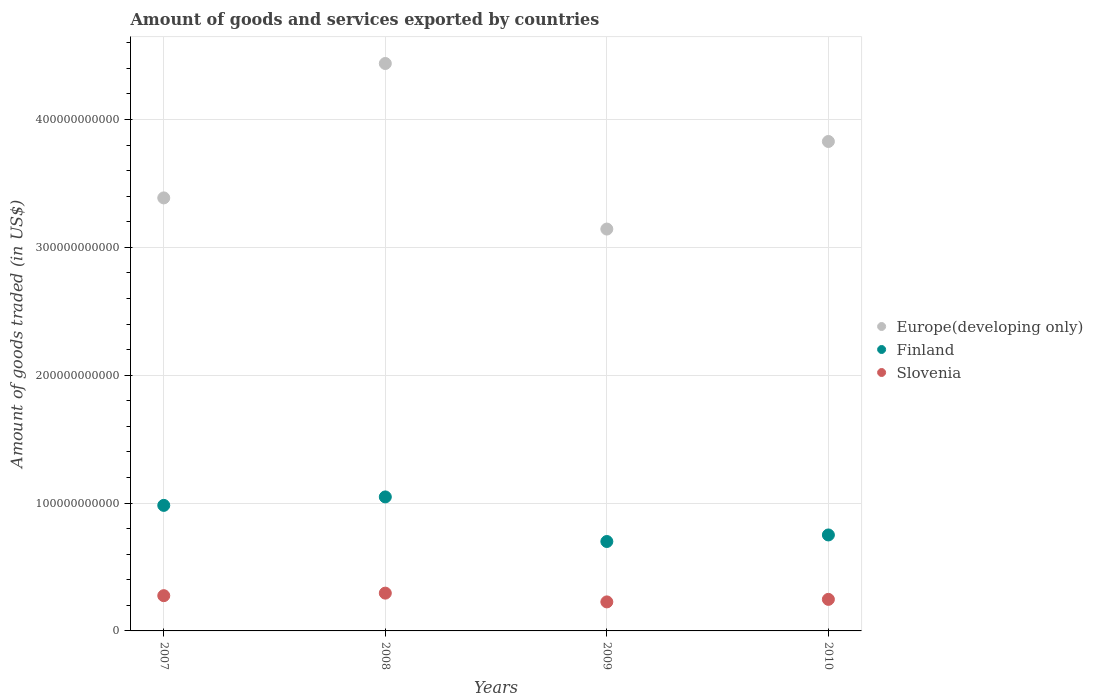Is the number of dotlines equal to the number of legend labels?
Keep it short and to the point. Yes. What is the total amount of goods and services exported in Finland in 2010?
Your answer should be very brief. 7.51e+1. Across all years, what is the maximum total amount of goods and services exported in Finland?
Provide a succinct answer. 1.05e+11. Across all years, what is the minimum total amount of goods and services exported in Slovenia?
Provide a short and direct response. 2.27e+1. What is the total total amount of goods and services exported in Slovenia in the graph?
Keep it short and to the point. 1.05e+11. What is the difference between the total amount of goods and services exported in Finland in 2007 and that in 2009?
Your answer should be compact. 2.83e+1. What is the difference between the total amount of goods and services exported in Slovenia in 2009 and the total amount of goods and services exported in Europe(developing only) in 2008?
Your answer should be compact. -4.21e+11. What is the average total amount of goods and services exported in Finland per year?
Your response must be concise. 8.70e+1. In the year 2007, what is the difference between the total amount of goods and services exported in Finland and total amount of goods and services exported in Europe(developing only)?
Offer a very short reply. -2.40e+11. What is the ratio of the total amount of goods and services exported in Finland in 2009 to that in 2010?
Keep it short and to the point. 0.93. Is the total amount of goods and services exported in Europe(developing only) in 2009 less than that in 2010?
Make the answer very short. Yes. Is the difference between the total amount of goods and services exported in Finland in 2009 and 2010 greater than the difference between the total amount of goods and services exported in Europe(developing only) in 2009 and 2010?
Offer a terse response. Yes. What is the difference between the highest and the second highest total amount of goods and services exported in Slovenia?
Provide a short and direct response. 1.98e+09. What is the difference between the highest and the lowest total amount of goods and services exported in Finland?
Provide a succinct answer. 3.49e+1. Is the total amount of goods and services exported in Slovenia strictly greater than the total amount of goods and services exported in Finland over the years?
Ensure brevity in your answer.  No. What is the difference between two consecutive major ticks on the Y-axis?
Your response must be concise. 1.00e+11. Does the graph contain grids?
Your response must be concise. Yes. Where does the legend appear in the graph?
Give a very brief answer. Center right. How many legend labels are there?
Make the answer very short. 3. How are the legend labels stacked?
Your response must be concise. Vertical. What is the title of the graph?
Provide a succinct answer. Amount of goods and services exported by countries. Does "Ethiopia" appear as one of the legend labels in the graph?
Ensure brevity in your answer.  No. What is the label or title of the Y-axis?
Your response must be concise. Amount of goods traded (in US$). What is the Amount of goods traded (in US$) of Europe(developing only) in 2007?
Make the answer very short. 3.39e+11. What is the Amount of goods traded (in US$) of Finland in 2007?
Your answer should be compact. 9.82e+1. What is the Amount of goods traded (in US$) in Slovenia in 2007?
Ensure brevity in your answer.  2.76e+1. What is the Amount of goods traded (in US$) of Europe(developing only) in 2008?
Offer a very short reply. 4.44e+11. What is the Amount of goods traded (in US$) in Finland in 2008?
Your response must be concise. 1.05e+11. What is the Amount of goods traded (in US$) in Slovenia in 2008?
Offer a very short reply. 2.96e+1. What is the Amount of goods traded (in US$) of Europe(developing only) in 2009?
Ensure brevity in your answer.  3.14e+11. What is the Amount of goods traded (in US$) of Finland in 2009?
Provide a succinct answer. 6.99e+1. What is the Amount of goods traded (in US$) in Slovenia in 2009?
Offer a very short reply. 2.27e+1. What is the Amount of goods traded (in US$) of Europe(developing only) in 2010?
Your answer should be compact. 3.83e+11. What is the Amount of goods traded (in US$) in Finland in 2010?
Your answer should be compact. 7.51e+1. What is the Amount of goods traded (in US$) in Slovenia in 2010?
Your answer should be compact. 2.47e+1. Across all years, what is the maximum Amount of goods traded (in US$) of Europe(developing only)?
Your answer should be very brief. 4.44e+11. Across all years, what is the maximum Amount of goods traded (in US$) of Finland?
Your answer should be compact. 1.05e+11. Across all years, what is the maximum Amount of goods traded (in US$) in Slovenia?
Give a very brief answer. 2.96e+1. Across all years, what is the minimum Amount of goods traded (in US$) of Europe(developing only)?
Ensure brevity in your answer.  3.14e+11. Across all years, what is the minimum Amount of goods traded (in US$) in Finland?
Give a very brief answer. 6.99e+1. Across all years, what is the minimum Amount of goods traded (in US$) of Slovenia?
Your response must be concise. 2.27e+1. What is the total Amount of goods traded (in US$) in Europe(developing only) in the graph?
Provide a short and direct response. 1.48e+12. What is the total Amount of goods traded (in US$) of Finland in the graph?
Ensure brevity in your answer.  3.48e+11. What is the total Amount of goods traded (in US$) of Slovenia in the graph?
Your response must be concise. 1.05e+11. What is the difference between the Amount of goods traded (in US$) of Europe(developing only) in 2007 and that in 2008?
Your response must be concise. -1.05e+11. What is the difference between the Amount of goods traded (in US$) in Finland in 2007 and that in 2008?
Keep it short and to the point. -6.61e+09. What is the difference between the Amount of goods traded (in US$) in Slovenia in 2007 and that in 2008?
Your response must be concise. -1.98e+09. What is the difference between the Amount of goods traded (in US$) in Europe(developing only) in 2007 and that in 2009?
Make the answer very short. 2.44e+1. What is the difference between the Amount of goods traded (in US$) of Finland in 2007 and that in 2009?
Offer a terse response. 2.83e+1. What is the difference between the Amount of goods traded (in US$) of Slovenia in 2007 and that in 2009?
Provide a short and direct response. 4.87e+09. What is the difference between the Amount of goods traded (in US$) of Europe(developing only) in 2007 and that in 2010?
Ensure brevity in your answer.  -4.41e+1. What is the difference between the Amount of goods traded (in US$) in Finland in 2007 and that in 2010?
Your answer should be compact. 2.31e+1. What is the difference between the Amount of goods traded (in US$) in Slovenia in 2007 and that in 2010?
Provide a short and direct response. 2.89e+09. What is the difference between the Amount of goods traded (in US$) of Europe(developing only) in 2008 and that in 2009?
Your answer should be very brief. 1.29e+11. What is the difference between the Amount of goods traded (in US$) in Finland in 2008 and that in 2009?
Provide a short and direct response. 3.49e+1. What is the difference between the Amount of goods traded (in US$) of Slovenia in 2008 and that in 2009?
Make the answer very short. 6.85e+09. What is the difference between the Amount of goods traded (in US$) in Europe(developing only) in 2008 and that in 2010?
Make the answer very short. 6.10e+1. What is the difference between the Amount of goods traded (in US$) of Finland in 2008 and that in 2010?
Give a very brief answer. 2.97e+1. What is the difference between the Amount of goods traded (in US$) in Slovenia in 2008 and that in 2010?
Your answer should be compact. 4.87e+09. What is the difference between the Amount of goods traded (in US$) of Europe(developing only) in 2009 and that in 2010?
Provide a succinct answer. -6.85e+1. What is the difference between the Amount of goods traded (in US$) of Finland in 2009 and that in 2010?
Offer a terse response. -5.12e+09. What is the difference between the Amount of goods traded (in US$) of Slovenia in 2009 and that in 2010?
Your answer should be compact. -1.98e+09. What is the difference between the Amount of goods traded (in US$) in Europe(developing only) in 2007 and the Amount of goods traded (in US$) in Finland in 2008?
Give a very brief answer. 2.34e+11. What is the difference between the Amount of goods traded (in US$) of Europe(developing only) in 2007 and the Amount of goods traded (in US$) of Slovenia in 2008?
Keep it short and to the point. 3.09e+11. What is the difference between the Amount of goods traded (in US$) of Finland in 2007 and the Amount of goods traded (in US$) of Slovenia in 2008?
Provide a succinct answer. 6.86e+1. What is the difference between the Amount of goods traded (in US$) in Europe(developing only) in 2007 and the Amount of goods traded (in US$) in Finland in 2009?
Offer a terse response. 2.69e+11. What is the difference between the Amount of goods traded (in US$) of Europe(developing only) in 2007 and the Amount of goods traded (in US$) of Slovenia in 2009?
Offer a terse response. 3.16e+11. What is the difference between the Amount of goods traded (in US$) in Finland in 2007 and the Amount of goods traded (in US$) in Slovenia in 2009?
Ensure brevity in your answer.  7.55e+1. What is the difference between the Amount of goods traded (in US$) of Europe(developing only) in 2007 and the Amount of goods traded (in US$) of Finland in 2010?
Provide a succinct answer. 2.64e+11. What is the difference between the Amount of goods traded (in US$) in Europe(developing only) in 2007 and the Amount of goods traded (in US$) in Slovenia in 2010?
Your answer should be very brief. 3.14e+11. What is the difference between the Amount of goods traded (in US$) of Finland in 2007 and the Amount of goods traded (in US$) of Slovenia in 2010?
Your response must be concise. 7.35e+1. What is the difference between the Amount of goods traded (in US$) in Europe(developing only) in 2008 and the Amount of goods traded (in US$) in Finland in 2009?
Offer a terse response. 3.74e+11. What is the difference between the Amount of goods traded (in US$) of Europe(developing only) in 2008 and the Amount of goods traded (in US$) of Slovenia in 2009?
Make the answer very short. 4.21e+11. What is the difference between the Amount of goods traded (in US$) of Finland in 2008 and the Amount of goods traded (in US$) of Slovenia in 2009?
Provide a short and direct response. 8.21e+1. What is the difference between the Amount of goods traded (in US$) of Europe(developing only) in 2008 and the Amount of goods traded (in US$) of Finland in 2010?
Your answer should be very brief. 3.69e+11. What is the difference between the Amount of goods traded (in US$) in Europe(developing only) in 2008 and the Amount of goods traded (in US$) in Slovenia in 2010?
Provide a succinct answer. 4.19e+11. What is the difference between the Amount of goods traded (in US$) of Finland in 2008 and the Amount of goods traded (in US$) of Slovenia in 2010?
Provide a short and direct response. 8.01e+1. What is the difference between the Amount of goods traded (in US$) of Europe(developing only) in 2009 and the Amount of goods traded (in US$) of Finland in 2010?
Keep it short and to the point. 2.39e+11. What is the difference between the Amount of goods traded (in US$) of Europe(developing only) in 2009 and the Amount of goods traded (in US$) of Slovenia in 2010?
Offer a very short reply. 2.90e+11. What is the difference between the Amount of goods traded (in US$) in Finland in 2009 and the Amount of goods traded (in US$) in Slovenia in 2010?
Your answer should be compact. 4.53e+1. What is the average Amount of goods traded (in US$) of Europe(developing only) per year?
Ensure brevity in your answer.  3.70e+11. What is the average Amount of goods traded (in US$) of Finland per year?
Your answer should be compact. 8.70e+1. What is the average Amount of goods traded (in US$) of Slovenia per year?
Your response must be concise. 2.61e+1. In the year 2007, what is the difference between the Amount of goods traded (in US$) of Europe(developing only) and Amount of goods traded (in US$) of Finland?
Your response must be concise. 2.40e+11. In the year 2007, what is the difference between the Amount of goods traded (in US$) in Europe(developing only) and Amount of goods traded (in US$) in Slovenia?
Offer a very short reply. 3.11e+11. In the year 2007, what is the difference between the Amount of goods traded (in US$) of Finland and Amount of goods traded (in US$) of Slovenia?
Provide a succinct answer. 7.06e+1. In the year 2008, what is the difference between the Amount of goods traded (in US$) in Europe(developing only) and Amount of goods traded (in US$) in Finland?
Keep it short and to the point. 3.39e+11. In the year 2008, what is the difference between the Amount of goods traded (in US$) of Europe(developing only) and Amount of goods traded (in US$) of Slovenia?
Keep it short and to the point. 4.14e+11. In the year 2008, what is the difference between the Amount of goods traded (in US$) in Finland and Amount of goods traded (in US$) in Slovenia?
Ensure brevity in your answer.  7.53e+1. In the year 2009, what is the difference between the Amount of goods traded (in US$) of Europe(developing only) and Amount of goods traded (in US$) of Finland?
Offer a terse response. 2.44e+11. In the year 2009, what is the difference between the Amount of goods traded (in US$) in Europe(developing only) and Amount of goods traded (in US$) in Slovenia?
Your response must be concise. 2.92e+11. In the year 2009, what is the difference between the Amount of goods traded (in US$) of Finland and Amount of goods traded (in US$) of Slovenia?
Your response must be concise. 4.72e+1. In the year 2010, what is the difference between the Amount of goods traded (in US$) of Europe(developing only) and Amount of goods traded (in US$) of Finland?
Make the answer very short. 3.08e+11. In the year 2010, what is the difference between the Amount of goods traded (in US$) of Europe(developing only) and Amount of goods traded (in US$) of Slovenia?
Give a very brief answer. 3.58e+11. In the year 2010, what is the difference between the Amount of goods traded (in US$) of Finland and Amount of goods traded (in US$) of Slovenia?
Provide a short and direct response. 5.04e+1. What is the ratio of the Amount of goods traded (in US$) of Europe(developing only) in 2007 to that in 2008?
Your response must be concise. 0.76. What is the ratio of the Amount of goods traded (in US$) of Finland in 2007 to that in 2008?
Offer a terse response. 0.94. What is the ratio of the Amount of goods traded (in US$) of Slovenia in 2007 to that in 2008?
Keep it short and to the point. 0.93. What is the ratio of the Amount of goods traded (in US$) in Europe(developing only) in 2007 to that in 2009?
Offer a very short reply. 1.08. What is the ratio of the Amount of goods traded (in US$) of Finland in 2007 to that in 2009?
Your answer should be very brief. 1.4. What is the ratio of the Amount of goods traded (in US$) of Slovenia in 2007 to that in 2009?
Your answer should be compact. 1.21. What is the ratio of the Amount of goods traded (in US$) in Europe(developing only) in 2007 to that in 2010?
Keep it short and to the point. 0.88. What is the ratio of the Amount of goods traded (in US$) of Finland in 2007 to that in 2010?
Ensure brevity in your answer.  1.31. What is the ratio of the Amount of goods traded (in US$) in Slovenia in 2007 to that in 2010?
Your response must be concise. 1.12. What is the ratio of the Amount of goods traded (in US$) in Europe(developing only) in 2008 to that in 2009?
Provide a succinct answer. 1.41. What is the ratio of the Amount of goods traded (in US$) of Finland in 2008 to that in 2009?
Ensure brevity in your answer.  1.5. What is the ratio of the Amount of goods traded (in US$) in Slovenia in 2008 to that in 2009?
Your answer should be very brief. 1.3. What is the ratio of the Amount of goods traded (in US$) in Europe(developing only) in 2008 to that in 2010?
Ensure brevity in your answer.  1.16. What is the ratio of the Amount of goods traded (in US$) in Finland in 2008 to that in 2010?
Offer a terse response. 1.4. What is the ratio of the Amount of goods traded (in US$) of Slovenia in 2008 to that in 2010?
Offer a terse response. 1.2. What is the ratio of the Amount of goods traded (in US$) in Europe(developing only) in 2009 to that in 2010?
Your answer should be compact. 0.82. What is the ratio of the Amount of goods traded (in US$) in Finland in 2009 to that in 2010?
Offer a terse response. 0.93. What is the ratio of the Amount of goods traded (in US$) in Slovenia in 2009 to that in 2010?
Your answer should be very brief. 0.92. What is the difference between the highest and the second highest Amount of goods traded (in US$) of Europe(developing only)?
Offer a terse response. 6.10e+1. What is the difference between the highest and the second highest Amount of goods traded (in US$) in Finland?
Offer a terse response. 6.61e+09. What is the difference between the highest and the second highest Amount of goods traded (in US$) of Slovenia?
Provide a short and direct response. 1.98e+09. What is the difference between the highest and the lowest Amount of goods traded (in US$) of Europe(developing only)?
Your answer should be very brief. 1.29e+11. What is the difference between the highest and the lowest Amount of goods traded (in US$) in Finland?
Your answer should be very brief. 3.49e+1. What is the difference between the highest and the lowest Amount of goods traded (in US$) of Slovenia?
Your answer should be compact. 6.85e+09. 